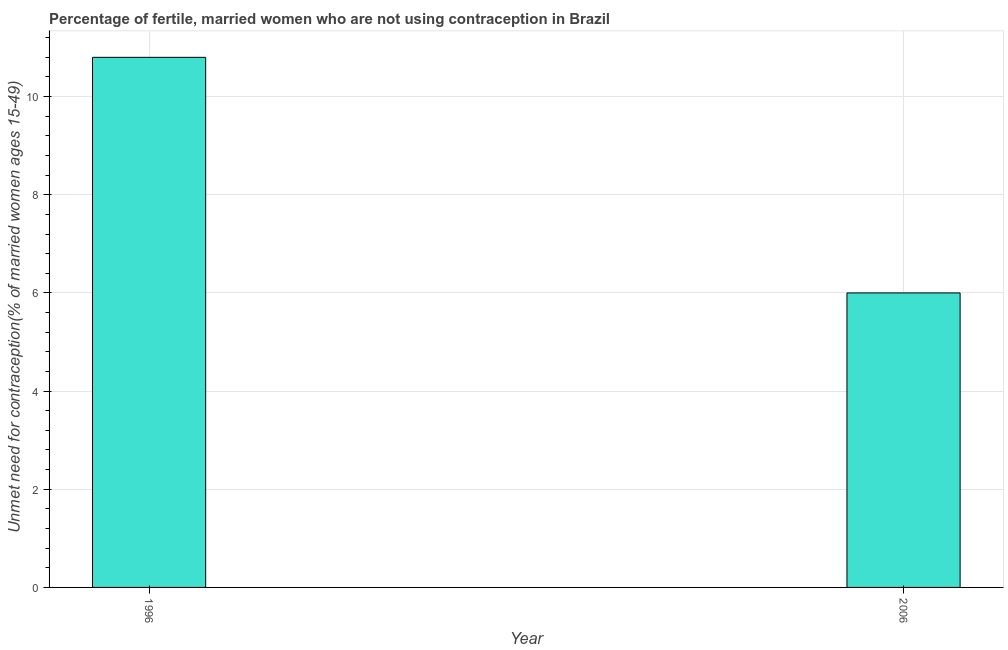Does the graph contain grids?
Offer a very short reply. Yes. What is the title of the graph?
Make the answer very short. Percentage of fertile, married women who are not using contraception in Brazil. What is the label or title of the Y-axis?
Give a very brief answer.  Unmet need for contraception(% of married women ages 15-49). Across all years, what is the maximum number of married women who are not using contraception?
Provide a succinct answer. 10.8. In which year was the number of married women who are not using contraception maximum?
Offer a very short reply. 1996. What is the sum of the number of married women who are not using contraception?
Your answer should be compact. 16.8. What is the average number of married women who are not using contraception per year?
Your answer should be very brief. 8.4. What is the ratio of the number of married women who are not using contraception in 1996 to that in 2006?
Your response must be concise. 1.8. Are the values on the major ticks of Y-axis written in scientific E-notation?
Offer a very short reply. No. What is the difference between the  Unmet need for contraception(% of married women ages 15-49) in 1996 and 2006?
Offer a very short reply. 4.8. 